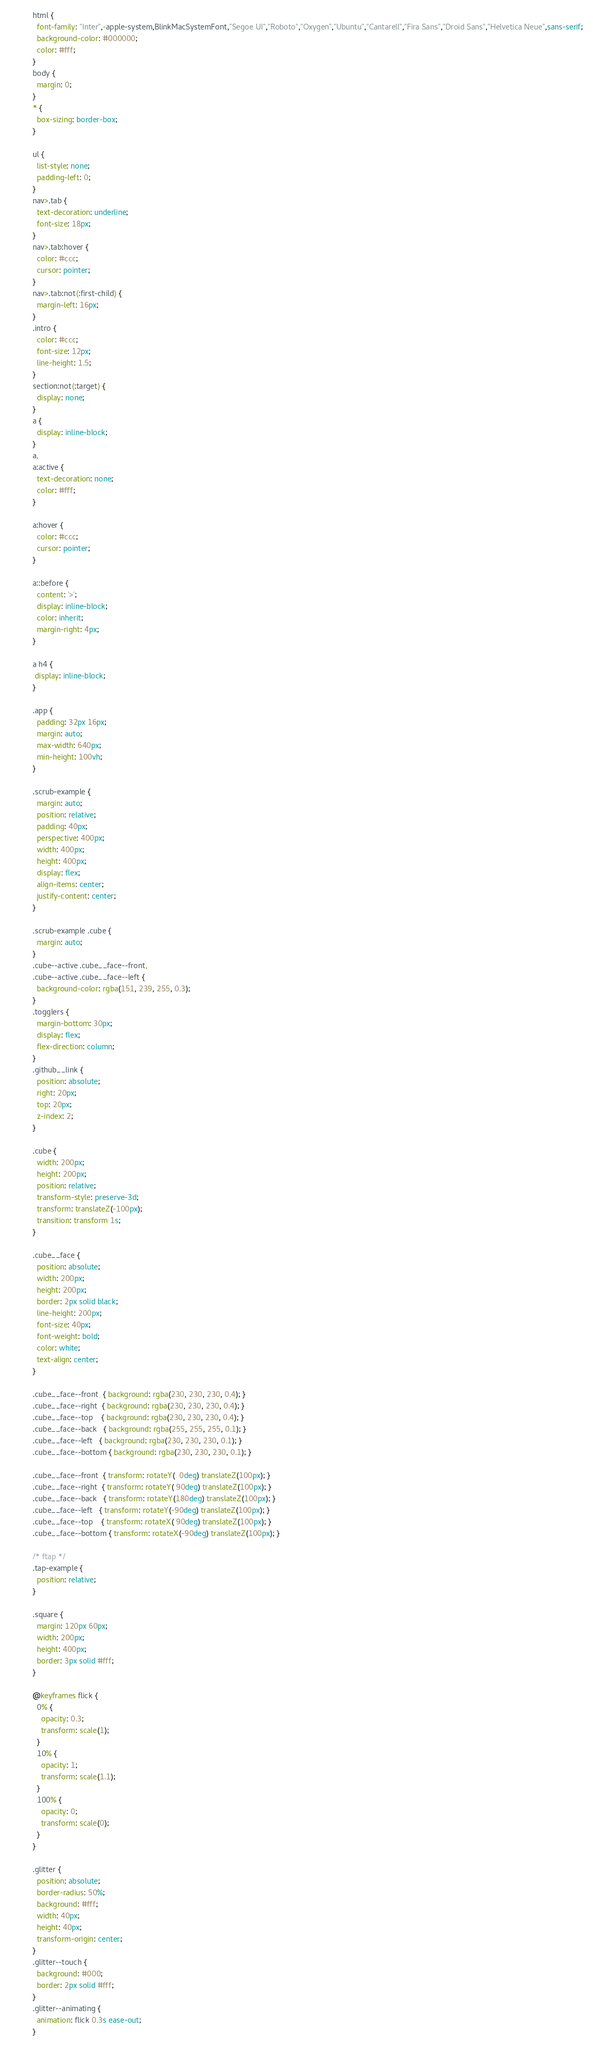<code> <loc_0><loc_0><loc_500><loc_500><_CSS_>html {
  font-family: "Inter",-apple-system,BlinkMacSystemFont,"Segoe UI","Roboto","Oxygen","Ubuntu","Cantarell","Fira Sans","Droid Sans","Helvetica Neue",sans-serif;
  background-color: #000000;
  color: #fff;
}
body {
  margin: 0;
}
* {
  box-sizing: border-box;
}

ul {
  list-style: none;
  padding-left: 0;
}
nav>.tab {
  text-decoration: underline;
  font-size: 18px;
}
nav>.tab:hover {
  color: #ccc;
  cursor: pointer;
}
nav>.tab:not(:first-child) {
  margin-left: 16px;
}
.intro {
  color: #ccc;
  font-size: 12px;
  line-height: 1.5;
}
section:not(:target) {
  display: none;
}
a {
  display: inline-block;
}
a,
a:active {
  text-decoration: none;
  color: #fff;
}

a:hover {
  color: #ccc;
  cursor: pointer;
}

a::before {
  content: '>';
  display: inline-block;
  color: inherit;
  margin-right: 4px;
}

a h4 {
 display: inline-block;
}

.app {
  padding: 32px 16px;
  margin: auto;
  max-width: 640px;
  min-height: 100vh;
}

.scrub-example {
  margin: auto;
  position: relative;
  padding: 40px;
  perspective: 400px;
  width: 400px;
  height: 400px;
  display: flex;
  align-items: center;
  justify-content: center;
}

.scrub-example .cube {
  margin: auto;
}
.cube--active .cube__face--front,
.cube--active .cube__face--left {
  background-color: rgba(151, 239, 255, 0.3);
}
.togglers {
  margin-bottom: 30px;
  display: flex;
  flex-direction: column;
}
.github__link {
  position: absolute;
  right: 20px;
  top: 20px;
  z-index: 2;
}

.cube {
  width: 200px;
  height: 200px;
  position: relative;
  transform-style: preserve-3d;
  transform: translateZ(-100px);
  transition: transform 1s;
}

.cube__face {
  position: absolute;
  width: 200px;
  height: 200px;
  border: 2px solid black;
  line-height: 200px;
  font-size: 40px;
  font-weight: bold;
  color: white;
  text-align: center;
}

.cube__face--front  { background: rgba(230, 230, 230, 0.4); }
.cube__face--right  { background: rgba(230, 230, 230, 0.4); }
.cube__face--top    { background: rgba(230, 230, 230, 0.4); }
.cube__face--back   { background: rgba(255, 255, 255, 0.1); }
.cube__face--left   { background: rgba(230, 230, 230, 0.1); }
.cube__face--bottom { background: rgba(230, 230, 230, 0.1); }

.cube__face--front  { transform: rotateY(  0deg) translateZ(100px); }
.cube__face--right  { transform: rotateY( 90deg) translateZ(100px); }
.cube__face--back   { transform: rotateY(180deg) translateZ(100px); }
.cube__face--left   { transform: rotateY(-90deg) translateZ(100px); }
.cube__face--top    { transform: rotateX( 90deg) translateZ(100px); }
.cube__face--bottom { transform: rotateX(-90deg) translateZ(100px); }

/* ftap */
.tap-example {
  position: relative;
}

.square {
  margin: 120px 60px;
  width: 200px;
  height: 400px;
  border: 3px solid #fff;
}

@keyframes flick {
  0% {
    opacity: 0.3;
    transform: scale(1);
  }
  10% {
    opacity: 1;
    transform: scale(1.1);
  }
  100% {
    opacity: 0;
    transform: scale(0);
  }
}

.glitter {
  position: absolute;
  border-radius: 50%;
  background: #fff;
  width: 40px;
  height: 40px;
  transform-origin: center;
}
.glitter--touch {
  background: #000;
  border: 2px solid #fff;
}
.glitter--animating {
  animation: flick 0.3s ease-out;
}
</code> 